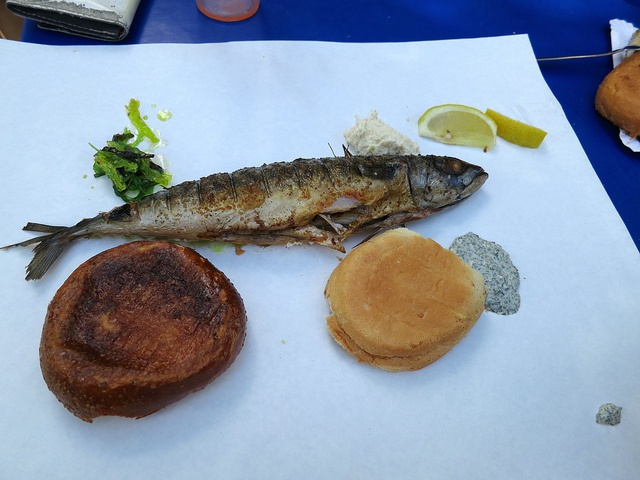Describe the objects in this image and their specific colors. I can see dining table in lightblue and black tones, sandwich in black, olive, tan, and brown tones, cup in black, purple, gray, and brown tones, and spoon in black, navy, gray, and darkgray tones in this image. 